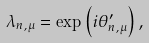<formula> <loc_0><loc_0><loc_500><loc_500>\lambda _ { n , \mu } = \exp \left ( i \theta ^ { \prime } _ { n , \mu } \right ) ,</formula> 